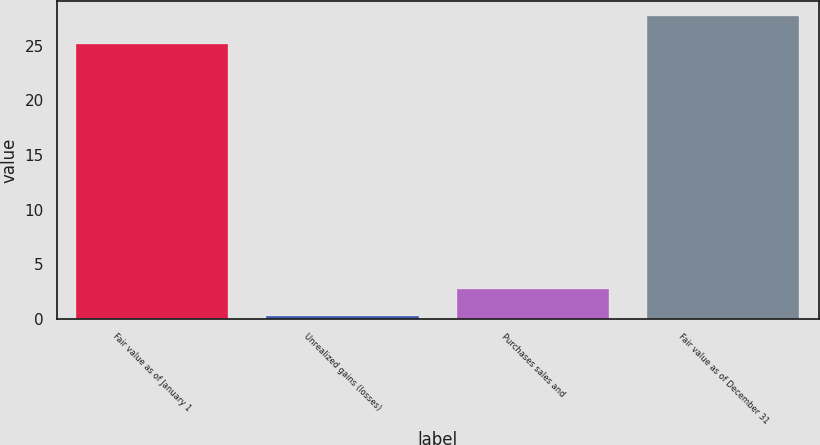Convert chart. <chart><loc_0><loc_0><loc_500><loc_500><bar_chart><fcel>Fair value as of January 1<fcel>Unrealized gains (losses)<fcel>Purchases sales and<fcel>Fair value as of December 31<nl><fcel>25.2<fcel>0.2<fcel>2.7<fcel>27.7<nl></chart> 